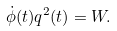<formula> <loc_0><loc_0><loc_500><loc_500>\dot { \phi } ( t ) q ^ { 2 } ( t ) = W .</formula> 